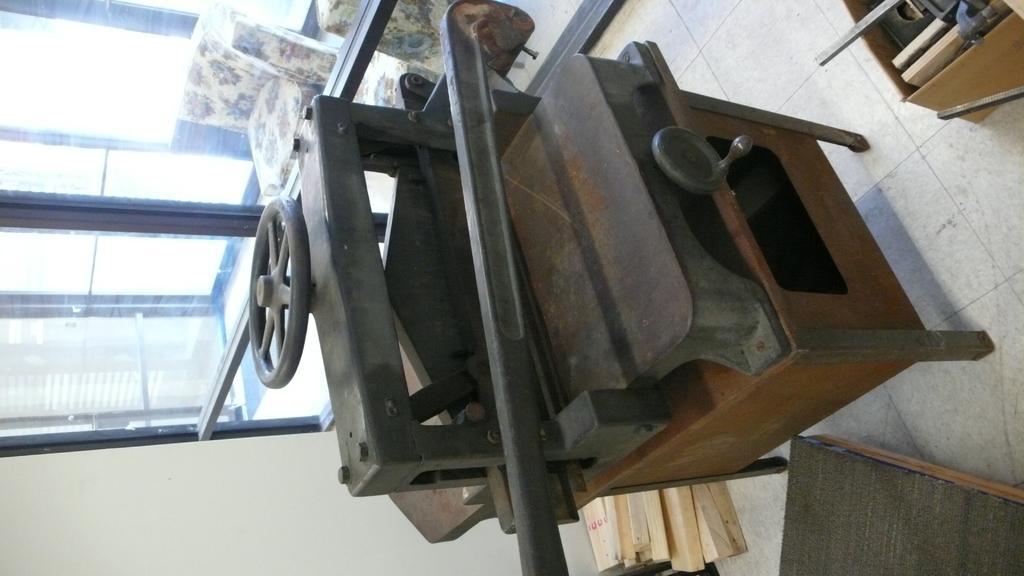Please provide a concise description of this image. In this picture I can see there is an iron machine in the middle of an image. On the left side there are glass walls, outside this, there are sofa chairs. At the bottom there are wooden planks in this image. 